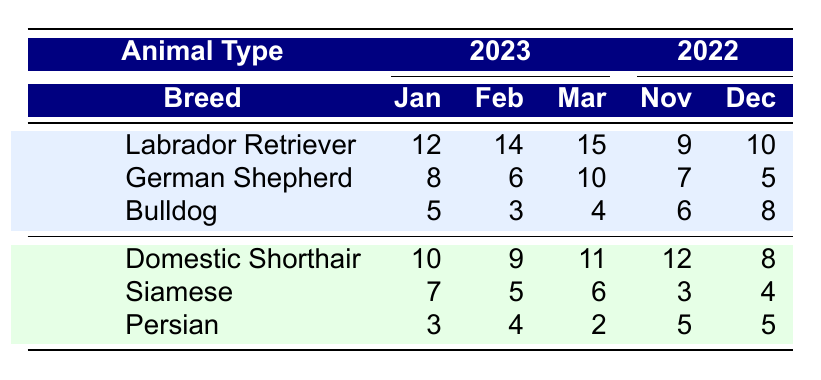What was the most adopted dog breed in March 2023? In March 2023, the number of adopted dogs was: Labrador Retriever (15), German Shepherd (10), Bulldog (4). The Labrador Retriever has the highest number of adoptions at 15.
Answer: Labrador Retriever How many cats were adopted in February 2023? In February 2023, the total number of adopted cats was: Domestic Shorthair (9), Siamese (5), Persian (4). Adding these values: 9 + 5 + 4 = 18.
Answer: 18 Did the number of adopted German Shepherds in 2022 exceed the number adopted in February 2023? In February 2023, the number of adopted German Shepherds was 6. In November 2022, the number was 7. Since 7 is greater than 6, the statement is true.
Answer: Yes What is the total number of Labradors adopted in 2023 so far? The adopted Labradors in 2023 are: January (12), February (14), March (15). Adding these values gives: 12 + 14 + 15 = 41.
Answer: 41 Which breed had the lowest adoption numbers in December 2022? In December 2022, the adoption numbers were: Labrador Retriever (10), German Shepherd (5), Bulldog (8). The German Shepherd has the lowest figure with 5.
Answer: German Shepherd What was the difference in the number of adopted Bulldogs between January 2023 and November 2022? In January 2023, Bulldogs adopted were 5, and in November 2022, they were 6. The difference is calculated as: 6 - 5 = 1.
Answer: 1 How many more Domestic Shorthairs were adopted in November 2022 than in January 2023? In November 2022, 12 Domestic Shorthairs were adopted, and in January 2023, 10 were adopted. The difference is 12 - 10 = 2.
Answer: 2 What is the total number of dog adoptions recorded for 2023 so far? The total number of dogs adopted in 2023 can be calculated by summing all data points: (12 + 14 + 15) for Labradors, (8 + 6 + 10) for German Shepherds, and (5 + 3 + 4) for Bulldogs: total = 12 + 14 + 15 + 8 + 6 + 10 + 5 + 3 + 4 = 77.
Answer: 77 